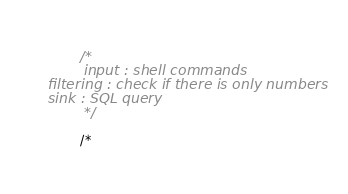<code> <loc_0><loc_0><loc_500><loc_500><_C#_>
        /*
        input : shell commands
filtering : check if there is only numbers
sink : SQL query
        */

        /*</code> 